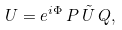Convert formula to latex. <formula><loc_0><loc_0><loc_500><loc_500>U = e ^ { i \Phi } \, P \, \tilde { U } \, Q ,</formula> 